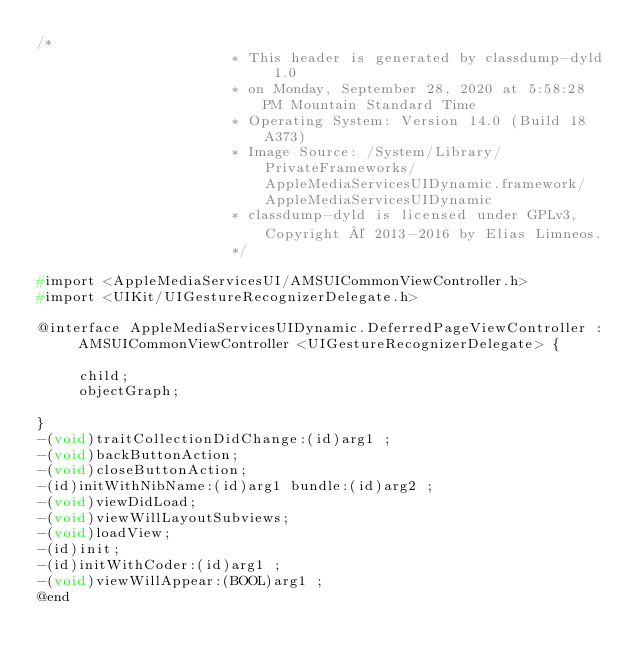Convert code to text. <code><loc_0><loc_0><loc_500><loc_500><_C_>/*
                       * This header is generated by classdump-dyld 1.0
                       * on Monday, September 28, 2020 at 5:58:28 PM Mountain Standard Time
                       * Operating System: Version 14.0 (Build 18A373)
                       * Image Source: /System/Library/PrivateFrameworks/AppleMediaServicesUIDynamic.framework/AppleMediaServicesUIDynamic
                       * classdump-dyld is licensed under GPLv3, Copyright © 2013-2016 by Elias Limneos.
                       */

#import <AppleMediaServicesUI/AMSUICommonViewController.h>
#import <UIKit/UIGestureRecognizerDelegate.h>

@interface AppleMediaServicesUIDynamic.DeferredPageViewController : AMSUICommonViewController <UIGestureRecognizerDelegate> {

	 child;
	 objectGraph;

}
-(void)traitCollectionDidChange:(id)arg1 ;
-(void)backButtonAction;
-(void)closeButtonAction;
-(id)initWithNibName:(id)arg1 bundle:(id)arg2 ;
-(void)viewDidLoad;
-(void)viewWillLayoutSubviews;
-(void)loadView;
-(id)init;
-(id)initWithCoder:(id)arg1 ;
-(void)viewWillAppear:(BOOL)arg1 ;
@end

</code> 